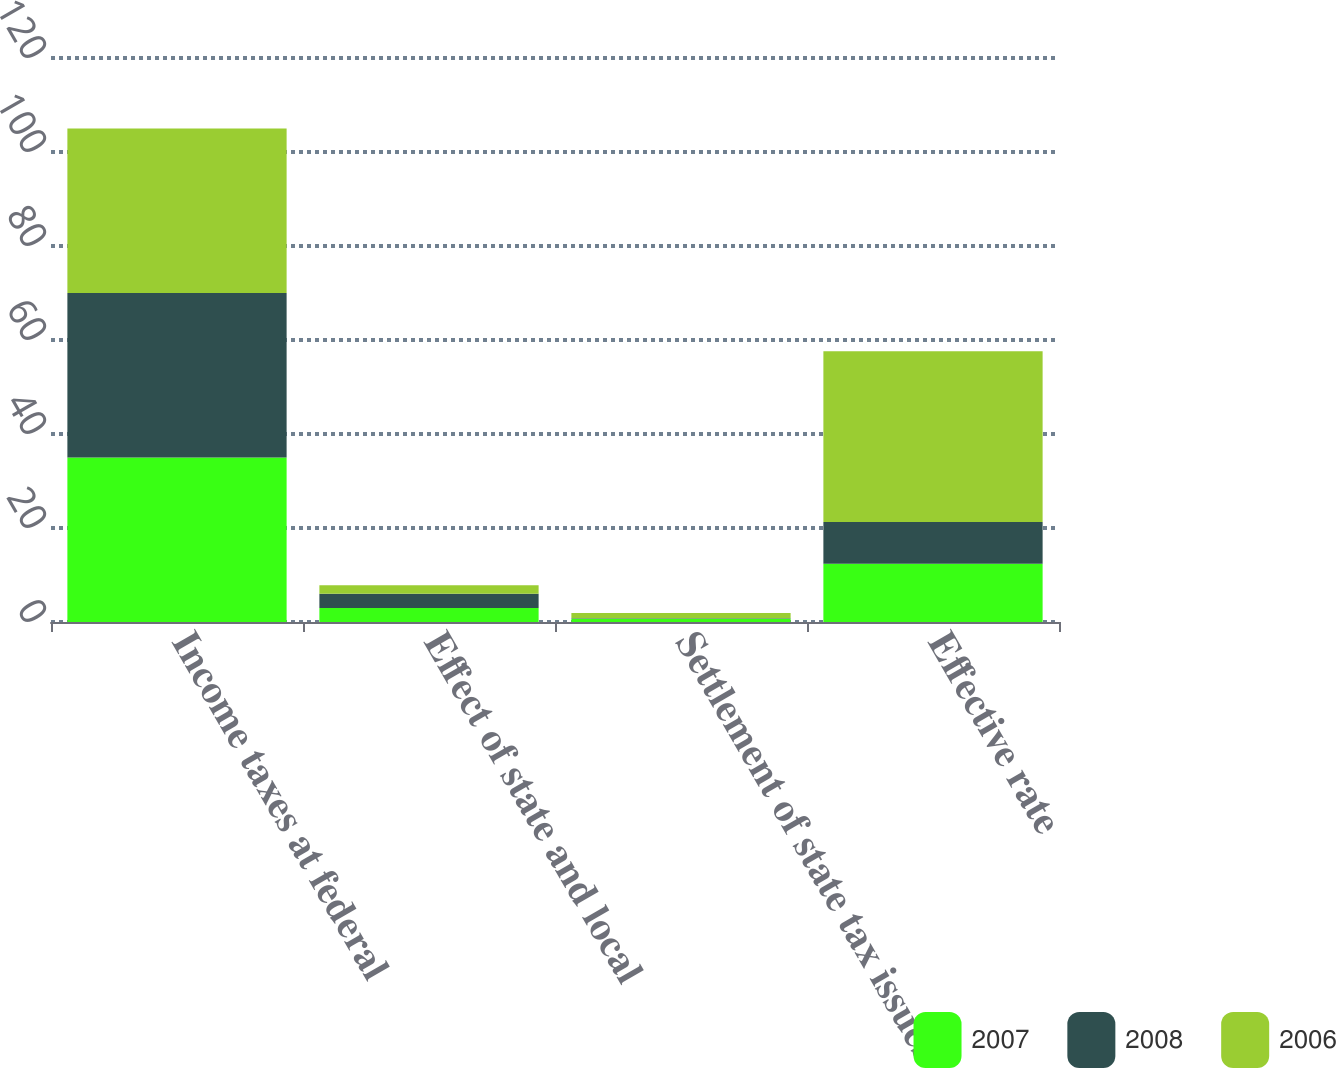Convert chart. <chart><loc_0><loc_0><loc_500><loc_500><stacked_bar_chart><ecel><fcel>Income taxes at federal<fcel>Effect of state and local<fcel>Settlement of state tax issues<fcel>Effective rate<nl><fcel>2007<fcel>35<fcel>3<fcel>0.7<fcel>12.4<nl><fcel>2008<fcel>35<fcel>3<fcel>0.1<fcel>8.9<nl><fcel>2006<fcel>35<fcel>1.8<fcel>1.1<fcel>36.3<nl></chart> 